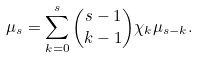<formula> <loc_0><loc_0><loc_500><loc_500>\mu _ { s } = \sum _ { k = 0 } ^ { s } { s - 1 \choose k - 1 } \chi _ { k } \mu _ { s - k } .</formula> 